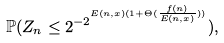<formula> <loc_0><loc_0><loc_500><loc_500>\mathbb { P } ( Z _ { n } \leq 2 ^ { - 2 ^ { E ( n , x ) ( 1 + \Theta ( \frac { f ( n ) } { E ( n , x ) } ) ) } } ) ,</formula> 